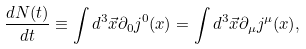Convert formula to latex. <formula><loc_0><loc_0><loc_500><loc_500>\frac { d N ( t ) } { d t } \equiv \int d ^ { 3 } \vec { x } \partial _ { 0 } j ^ { 0 } ( x ) = \int d ^ { 3 } \vec { x } \partial _ { \mu } j ^ { \mu } ( x ) ,</formula> 